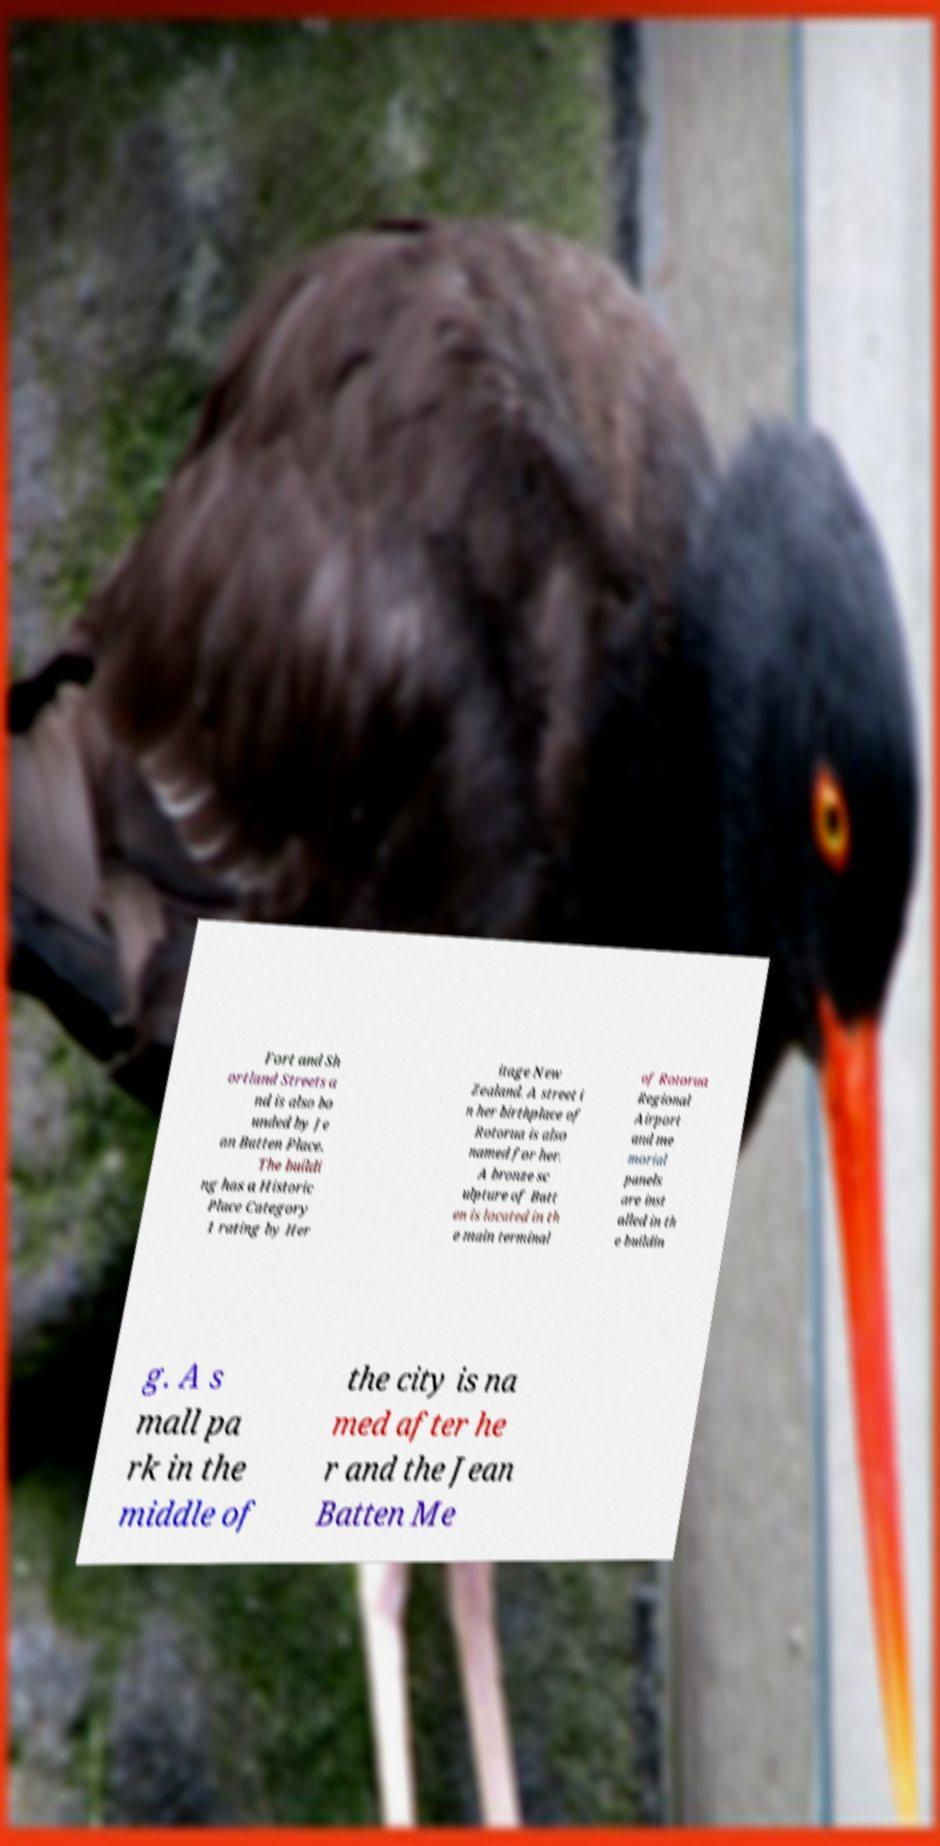Please identify and transcribe the text found in this image. Fort and Sh ortland Streets a nd is also bo unded by Je an Batten Place. The buildi ng has a Historic Place Category 1 rating by Her itage New Zealand. A street i n her birthplace of Rotorua is also named for her. A bronze sc ulpture of Batt en is located in th e main terminal of Rotorua Regional Airport and me morial panels are inst alled in th e buildin g. A s mall pa rk in the middle of the city is na med after he r and the Jean Batten Me 